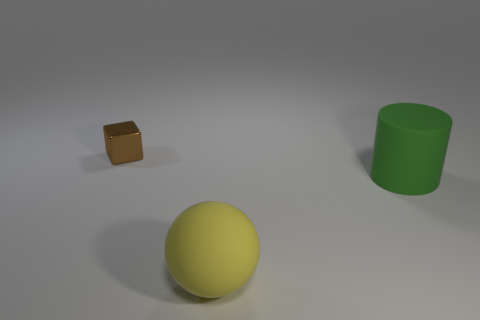Is there anything else that has the same size as the brown metallic cube?
Ensure brevity in your answer.  No. What size is the object that is in front of the shiny object and to the left of the green cylinder?
Offer a terse response. Large. How many large gray matte cubes are there?
Your answer should be compact. 0. There is a green cylinder that is the same size as the yellow thing; what is it made of?
Your answer should be compact. Rubber. Is there a yellow matte ball that has the same size as the green matte cylinder?
Your answer should be very brief. Yes. There is a big object that is to the left of the large green thing; does it have the same color as the rubber thing that is behind the big yellow rubber object?
Your answer should be very brief. No. What number of metal things are either green cylinders or blue cylinders?
Provide a succinct answer. 0. There is a matte object on the right side of the big rubber thing that is in front of the green matte thing; how many big yellow objects are behind it?
Your answer should be very brief. 0. There is a green object that is made of the same material as the large yellow ball; what size is it?
Provide a short and direct response. Large. There is a thing that is behind the green matte thing; is its size the same as the big green matte cylinder?
Keep it short and to the point. No. 